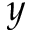Convert formula to latex. <formula><loc_0><loc_0><loc_500><loc_500>y</formula> 